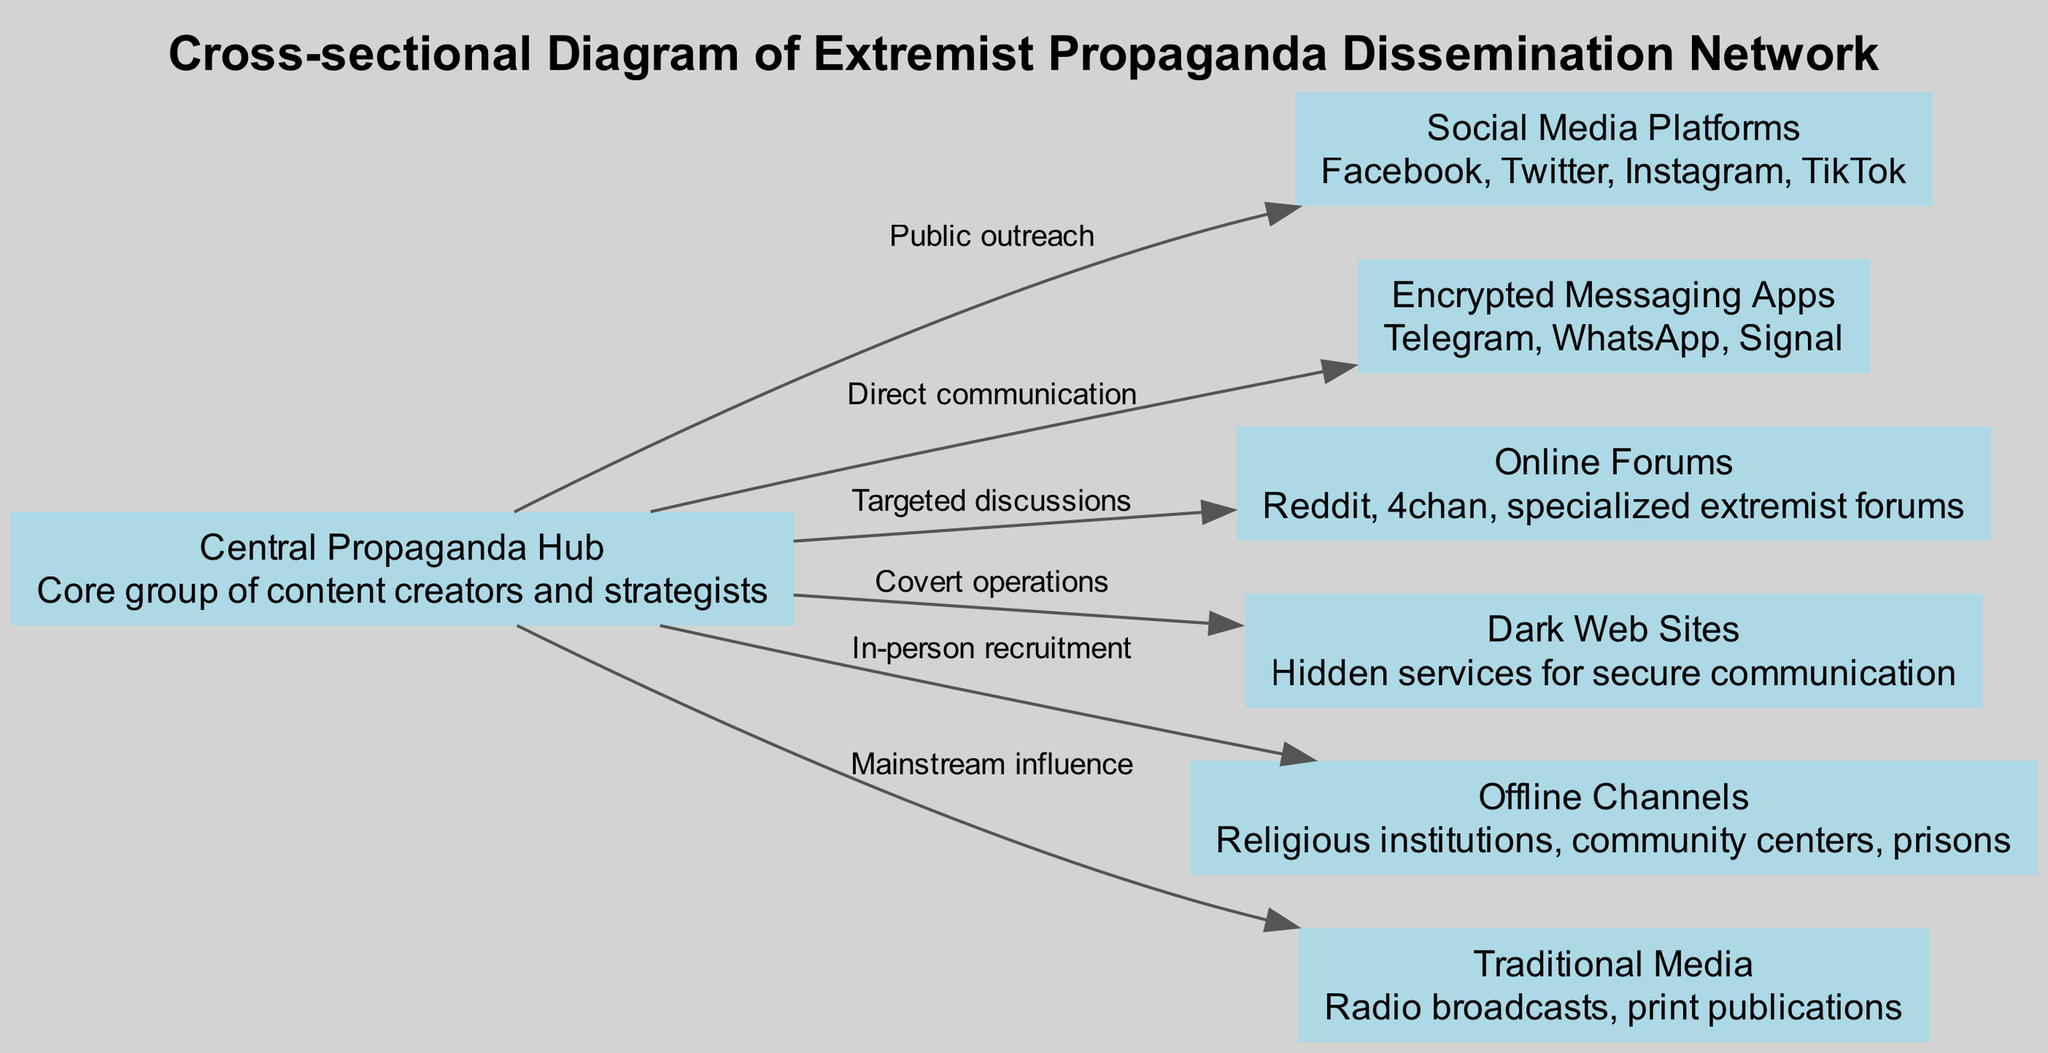What is the central node in the diagram? The central node in the diagram is the "Central Propaganda Hub." It is identified directly in the visual representation as the core group responsible for content creation and strategy.
Answer: Central Propaganda Hub How many online channels are used in the network? The network features four online channels: "Social Media Platforms," "Encrypted Messaging Apps," "Online Forums," and "Dark Web Sites." These nodes can be counted directly based on their distinct representations in the diagram.
Answer: 4 What is the connection type from the Central Propaganda Hub to Offline Channels? The connection type is labeled "In-person recruitment." By tracing the edge connecting the central hub to the offline channels, the specific label describes the nature of this connection.
Answer: In-person recruitment Which node is specifically related to "covert operations"? The node specifically related to "covert operations" is "Dark Web Sites." This is found by reviewing the edge that connects the central hub to the dark web, which is noted for this type of activity.
Answer: Dark Web Sites What are the main traditional media channels illustrated in the diagram? The main traditional media channel illustrated is "Traditional Media" which encompasses "Radio broadcasts" and "print publications." It is important to identify these descriptions to understand their roles in the network.
Answer: Traditional Media Which online platform is designed for targeted discussions? The platform designed for "targeted discussions" is "Online Forums." This is evident from the labeling of the edge that connects the central hub to forums, outlining their function within the network.
Answer: Online Forums How many edges connect the Central Propaganda Hub to other nodes? There are six edges connecting the Central Propaganda Hub to other nodes. Counting each unique line of communication directly shows how many connections exist from this central node.
Answer: 6 What type of recruitment involves Offline Channels? Offline Channels involve "In-person recruitment." This connection is labeled specifically on the edge from the central hub to offline channels, indicating the method of recruitment employed.
Answer: In-person recruitment Which platforms are considered social media in the diagram? The platforms considered social media are "Facebook," "Twitter," "Instagram," and "TikTok." This information is found within the description associated with the "Social Media Platforms" node.
Answer: Facebook, Twitter, Instagram, TikTok 